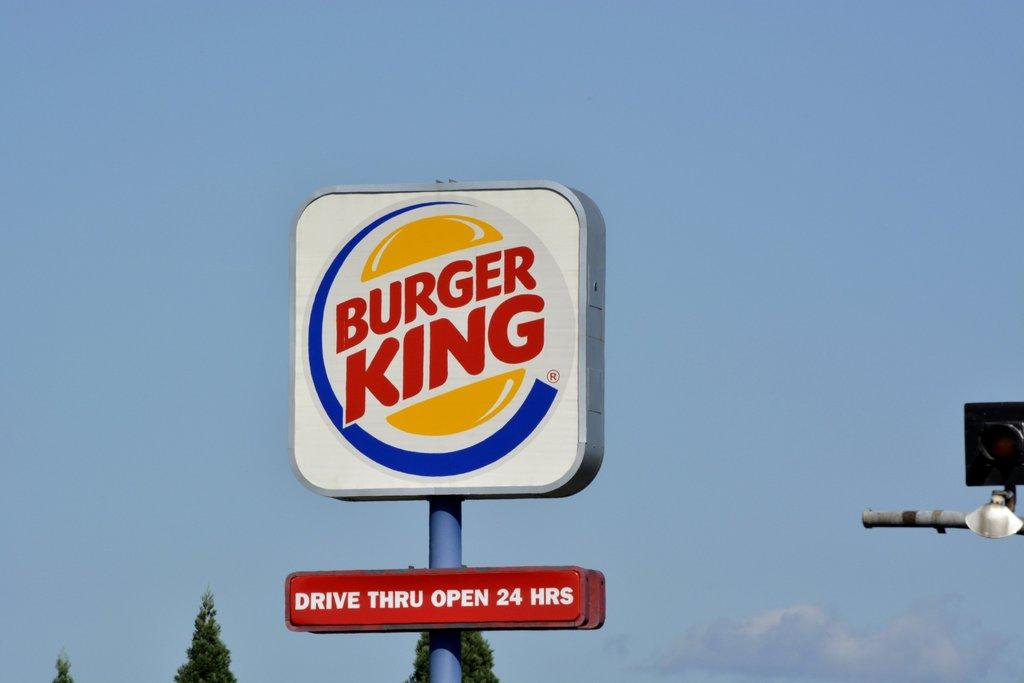<image>
Describe the image concisely. A burger king sign that says drive thru open 24 hours 